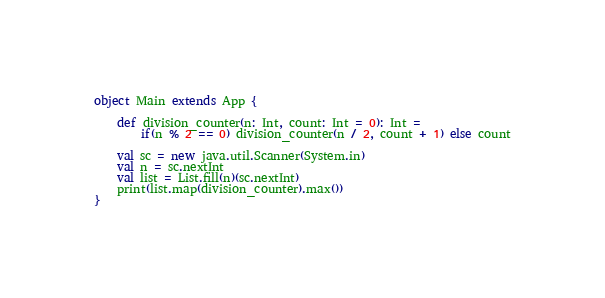<code> <loc_0><loc_0><loc_500><loc_500><_Scala_>object Main extends App {

    def division_counter(n: Int, count: Int = 0): Int =
        if(n % 2 == 0) division_counter(n / 2, count + 1) else count
    
    val sc = new java.util.Scanner(System.in)
    val n = sc.nextInt
    val list = List.fill(n)(sc.nextInt)
    print(list.map(division_counter).max())
}
</code> 